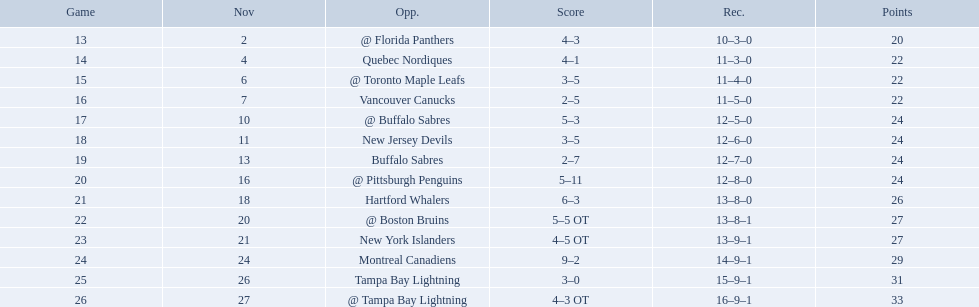Who did the philadelphia flyers play in game 17? @ Buffalo Sabres. What was the score of the november 10th game against the buffalo sabres? 5–3. Which team in the atlantic division had less points than the philadelphia flyers? Tampa Bay Lightning. What were the scores? @ Florida Panthers, 4–3, Quebec Nordiques, 4–1, @ Toronto Maple Leafs, 3–5, Vancouver Canucks, 2–5, @ Buffalo Sabres, 5–3, New Jersey Devils, 3–5, Buffalo Sabres, 2–7, @ Pittsburgh Penguins, 5–11, Hartford Whalers, 6–3, @ Boston Bruins, 5–5 OT, New York Islanders, 4–5 OT, Montreal Canadiens, 9–2, Tampa Bay Lightning, 3–0, @ Tampa Bay Lightning, 4–3 OT. What score was the closest? New York Islanders, 4–5 OT. What team had that score? New York Islanders. 